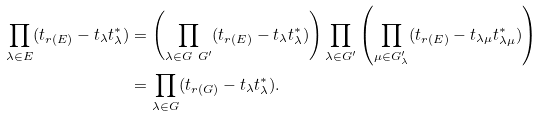Convert formula to latex. <formula><loc_0><loc_0><loc_500><loc_500>\prod _ { \lambda \in E } ( t _ { r ( E ) } - t _ { \lambda } t ^ { * } _ { \lambda } ) & = \left ( \prod _ { \lambda \in G \ G ^ { \prime } } ( t _ { r ( E ) } - t _ { \lambda } t ^ { * } _ { \lambda } ) \right ) \prod _ { \lambda \in G ^ { \prime } } \left ( \prod _ { \mu \in G ^ { \prime } _ { \lambda } } ( t _ { r ( E ) } - t _ { \lambda \mu } t ^ { * } _ { \lambda \mu } ) \right ) \\ & = \prod _ { \lambda \in G } ( t _ { r ( G ) } - t _ { \lambda } t ^ { * } _ { \lambda } ) .</formula> 